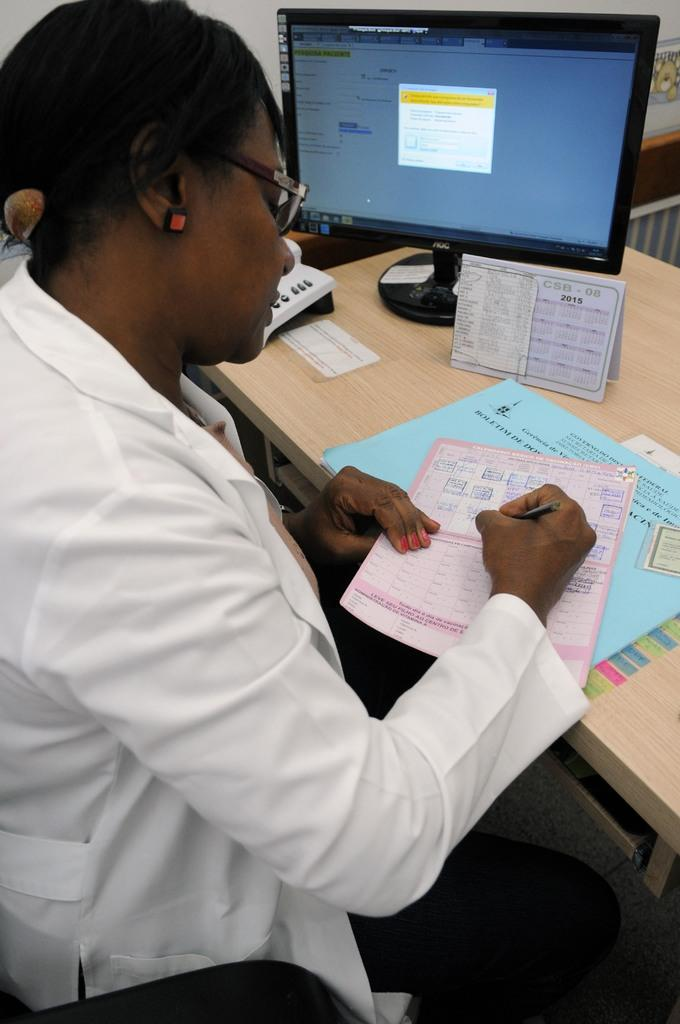<image>
Describe the image concisely. A woman has a blue paper on her desk whose header starts with the letter B. 